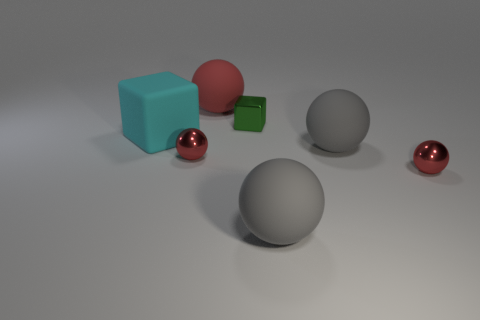Does the matte sphere that is behind the cyan thing have the same size as the small block?
Ensure brevity in your answer.  No. What is the shape of the tiny thing that is both right of the red rubber sphere and in front of the rubber cube?
Your response must be concise. Sphere. There is a red object that is made of the same material as the big block; what is its shape?
Offer a terse response. Sphere. Are there any tiny cyan rubber spheres?
Provide a succinct answer. No. Are there any large rubber cubes in front of the metallic object on the left side of the big red matte object?
Ensure brevity in your answer.  No. There is another thing that is the same shape as the cyan object; what is its material?
Make the answer very short. Metal. Is the number of tiny blocks greater than the number of things?
Provide a succinct answer. No. There is a matte object that is both to the left of the small block and in front of the tiny green thing; what color is it?
Ensure brevity in your answer.  Cyan. What number of other objects are there of the same material as the big cyan thing?
Your answer should be compact. 3. Are there fewer large matte cylinders than red rubber spheres?
Keep it short and to the point. Yes. 